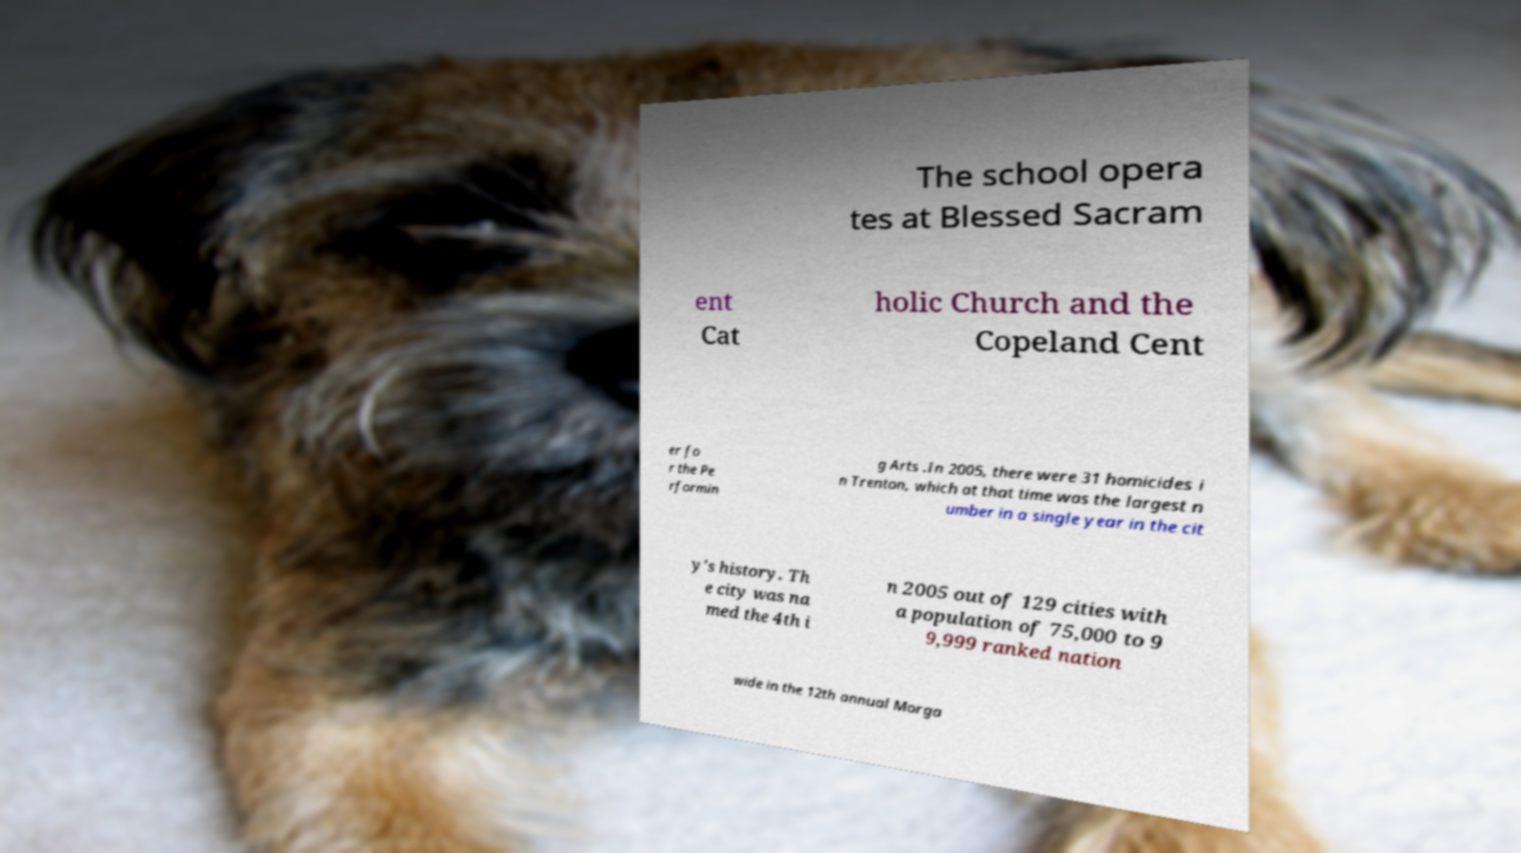Please identify and transcribe the text found in this image. The school opera tes at Blessed Sacram ent Cat holic Church and the Copeland Cent er fo r the Pe rformin g Arts .In 2005, there were 31 homicides i n Trenton, which at that time was the largest n umber in a single year in the cit y's history. Th e city was na med the 4th i n 2005 out of 129 cities with a population of 75,000 to 9 9,999 ranked nation wide in the 12th annual Morga 